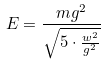<formula> <loc_0><loc_0><loc_500><loc_500>E = \frac { m g ^ { 2 } } { \sqrt { 5 \cdot \frac { w ^ { 2 } } { g ^ { 2 } } } }</formula> 